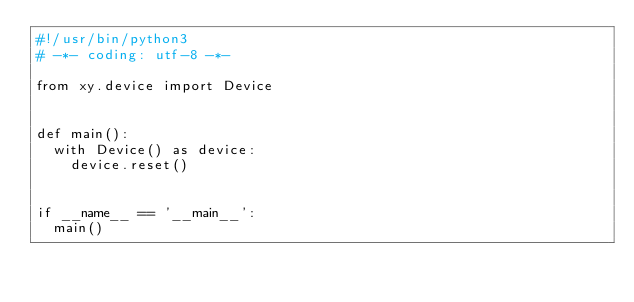<code> <loc_0><loc_0><loc_500><loc_500><_Python_>#!/usr/bin/python3
# -*- coding: utf-8 -*-

from xy.device import Device


def main():
  with Device() as device:
    device.reset()


if __name__ == '__main__':
  main()

</code> 